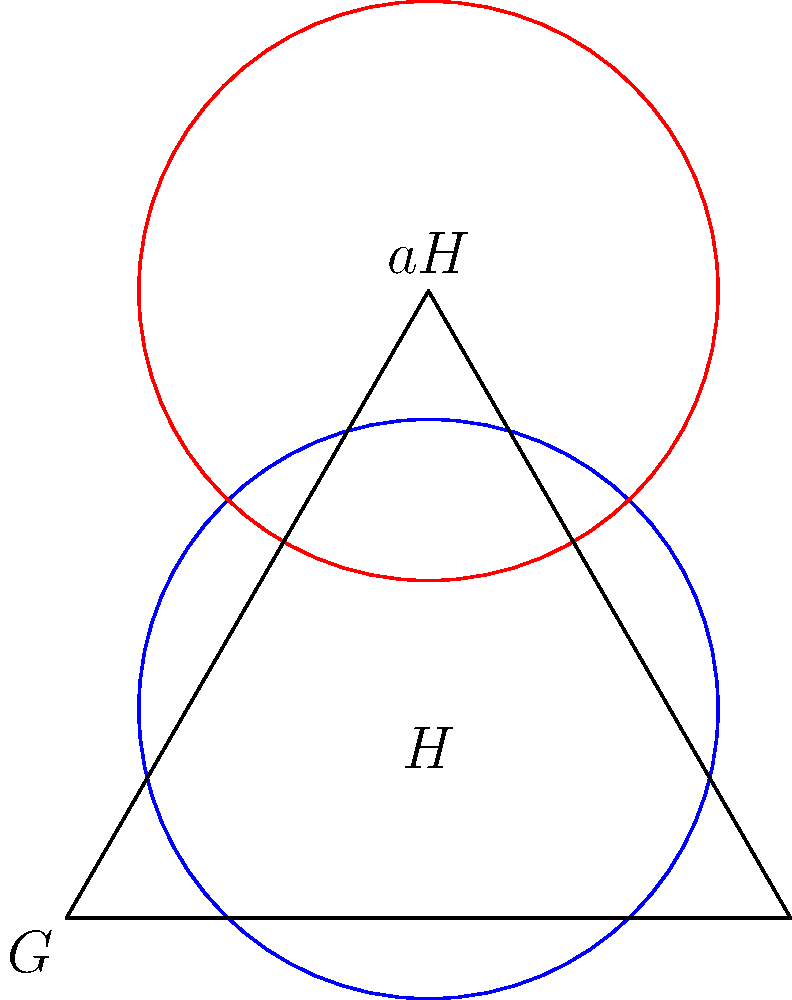Consider a group $G$ represented by the equilateral triangle in the Venn diagram, where $H$ is a subgroup of $G$. The blue circle represents the subgroup $H$, and the red circle represents a left coset $aH$ for some $a \in G$. Based on this representation, what can we conclude about the order of $H$ relative to the order of $G$? Express your answer as a fraction. Let's approach this step-by-step:

1) In group theory, cosets partition a group into equal-sized subsets. This means that all cosets of a subgroup have the same size as the subgroup itself.

2) In the diagram, we can see that the blue circle (representing $H$) and the red circle (representing $aH$) are the same size.

3) The cosets $H$ and $aH$ do not overlap, which is consistent with the properties of cosets when $a \notin H$.

4) Together, these two circles (representing $H$ and $aH$) appear to cover approximately 2/3 of the area of the triangle (representing $G$).

5) This visual representation suggests that there are three cosets of $H$ in $G$, each covering 1/3 of $G$.

6) In group theory terms, this implies that the index of $H$ in $G$ is 3, i.e., $[G:H] = 3$.

7) The index is defined as $[G:H] = \frac{|G|}{|H|}$, where $|G|$ and $|H|$ represent the orders of $G$ and $H$ respectively.

8) Therefore, $\frac{|G|}{|H|} = 3$, or equivalently, $\frac{|H|}{|G|} = \frac{1}{3}$.
Answer: $\frac{1}{3}$ 